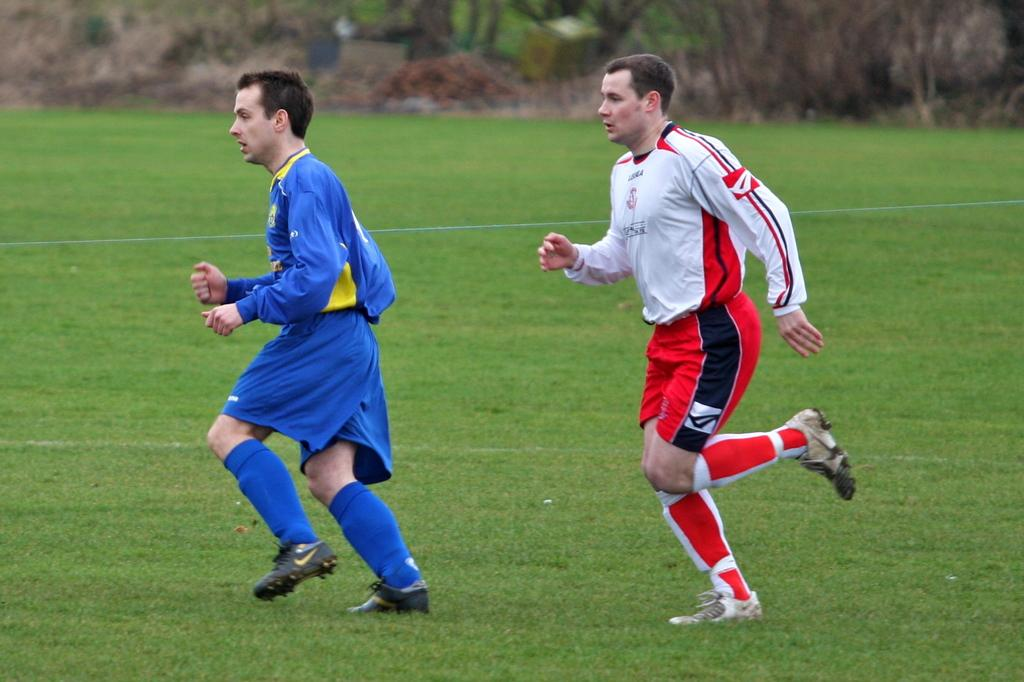How many people are in the image? There are two men in the image. What are the men doing in the image? The men are running on the grass. Can you describe the background of the image? The background of the image is blurred. What type of vegetation is visible at the top of the image? Plants are visible at the top of the image. What else can be seen at the top of the image besides plants? There are objects present at the top of the image. What type of creature is hiding among the plants at the top of the image? There is no creature present among the plants at the top of the image. What type of cabbage can be seen growing in the image? There is no cabbage present in the image. 